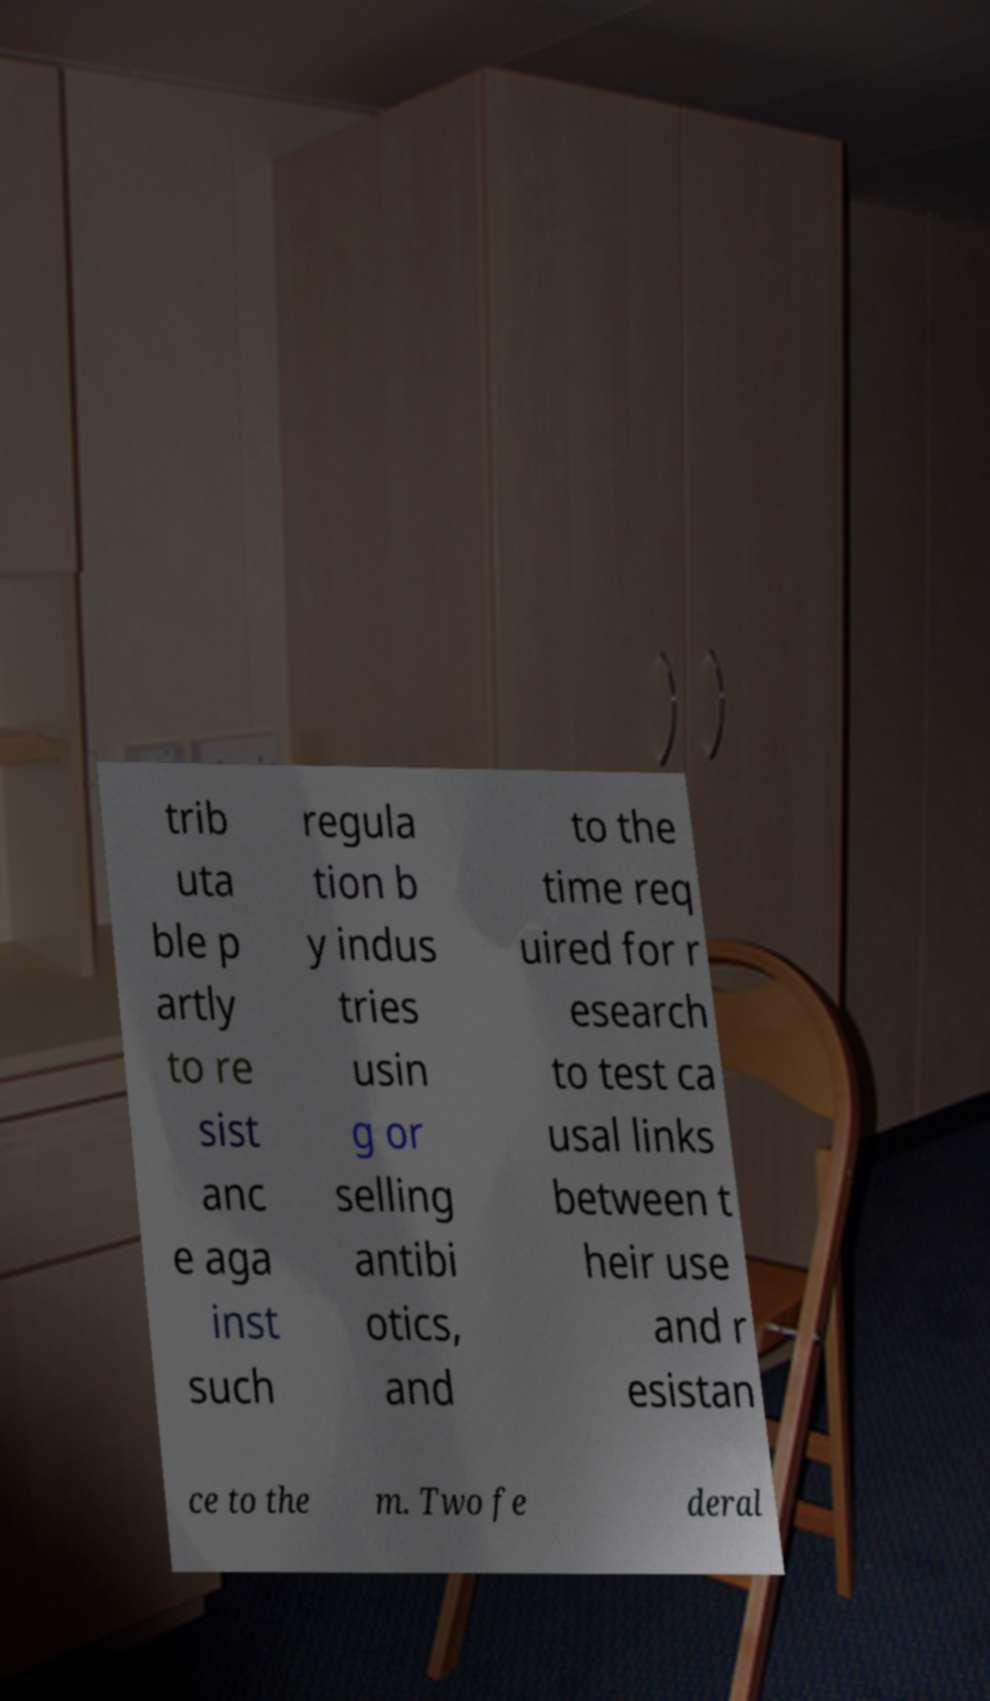Please read and relay the text visible in this image. What does it say? trib uta ble p artly to re sist anc e aga inst such regula tion b y indus tries usin g or selling antibi otics, and to the time req uired for r esearch to test ca usal links between t heir use and r esistan ce to the m. Two fe deral 